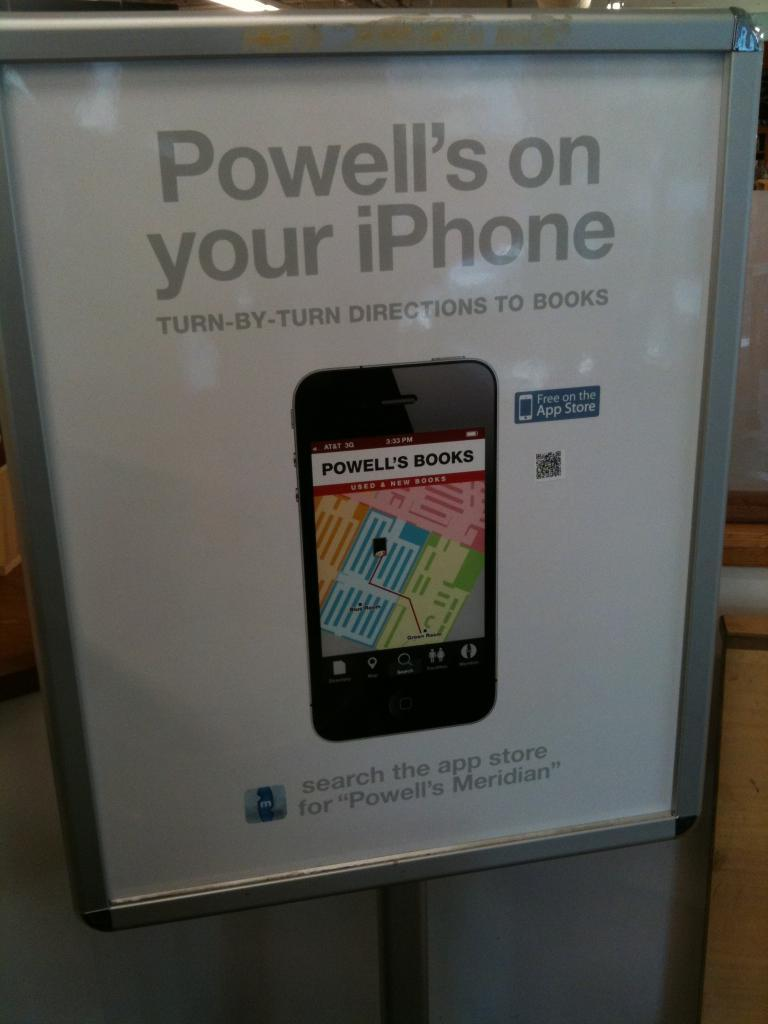<image>
Relay a brief, clear account of the picture shown. An advertisement for turn by turn directions to books. 